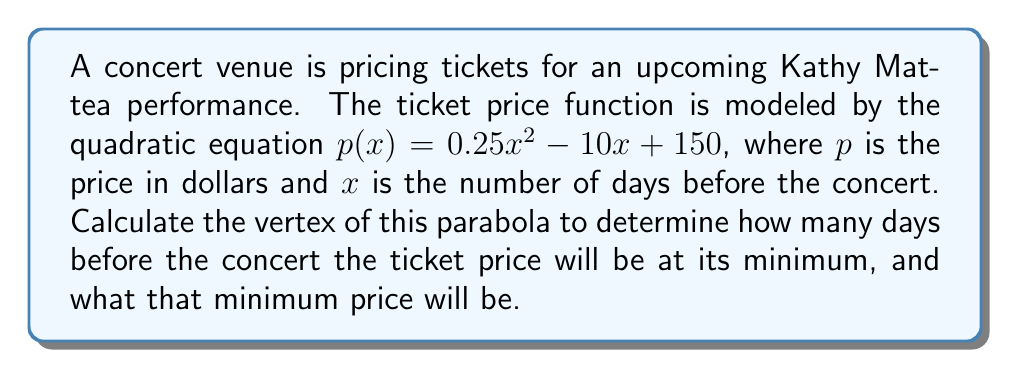Help me with this question. To find the vertex of a parabola given in the form $f(x) = ax^2 + bx + c$, we can use the formula:

$x = -\frac{b}{2a}$

Where $a$ and $b$ are the coefficients of $x^2$ and $x$ respectively.

In this case, we have $p(x) = 0.25x^2 - 10x + 150$, so:

$a = 0.25$
$b = -10$

Plugging these into the formula:

$x = -\frac{-10}{2(0.25)} = \frac{10}{0.5} = 20$

This means the x-coordinate of the vertex is 20.

To find the y-coordinate (the minimum price), we substitute x = 20 into the original equation:

$p(20) = 0.25(20)^2 - 10(20) + 150$
$= 0.25(400) - 200 + 150$
$= 100 - 200 + 150$
$= 50$

Therefore, the vertex is at the point (20, 50).
Answer: The vertex of the parabola is at (20, 50). This means the minimum ticket price of $50 will occur 20 days before the concert. 